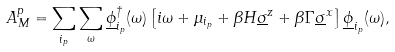<formula> <loc_0><loc_0><loc_500><loc_500>A _ { M } ^ { p } = \sum _ { i _ { p } } \sum _ { \omega } \underline { \phi } _ { i _ { p } } ^ { \dag } ( \omega ) \left [ i \omega + \mu _ { i _ { p } } + \beta H \underline { \sigma } ^ { z } + \beta \Gamma \underline { \sigma } ^ { x } \right ] \underline { \phi } _ { i _ { p } } ( \omega ) ,</formula> 